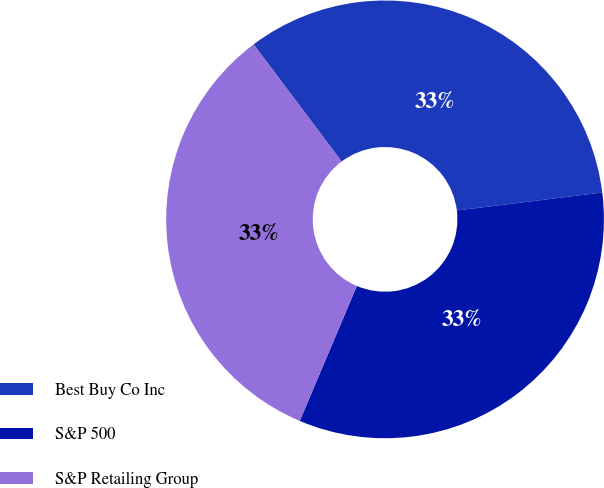Convert chart to OTSL. <chart><loc_0><loc_0><loc_500><loc_500><pie_chart><fcel>Best Buy Co Inc<fcel>S&P 500<fcel>S&P Retailing Group<nl><fcel>33.3%<fcel>33.33%<fcel>33.37%<nl></chart> 